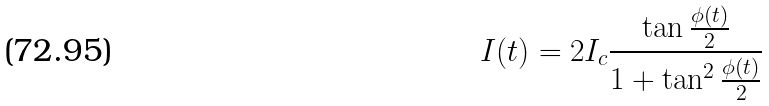<formula> <loc_0><loc_0><loc_500><loc_500>I ( t ) = 2 I _ { c } \frac { \tan \frac { \phi ( t ) } { 2 } } { 1 + \tan ^ { 2 } \frac { \phi ( t ) } { 2 } }</formula> 